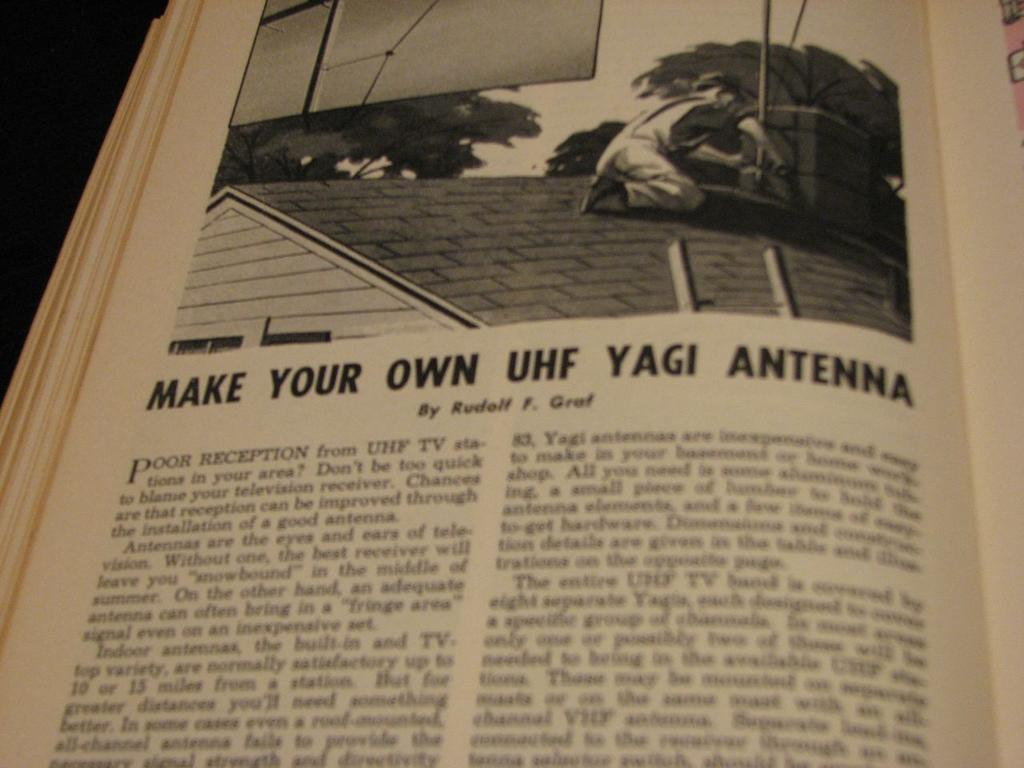<image>
Relay a brief, clear account of the picture shown. You can make your own UHF Yagi Antenna following the steps. 